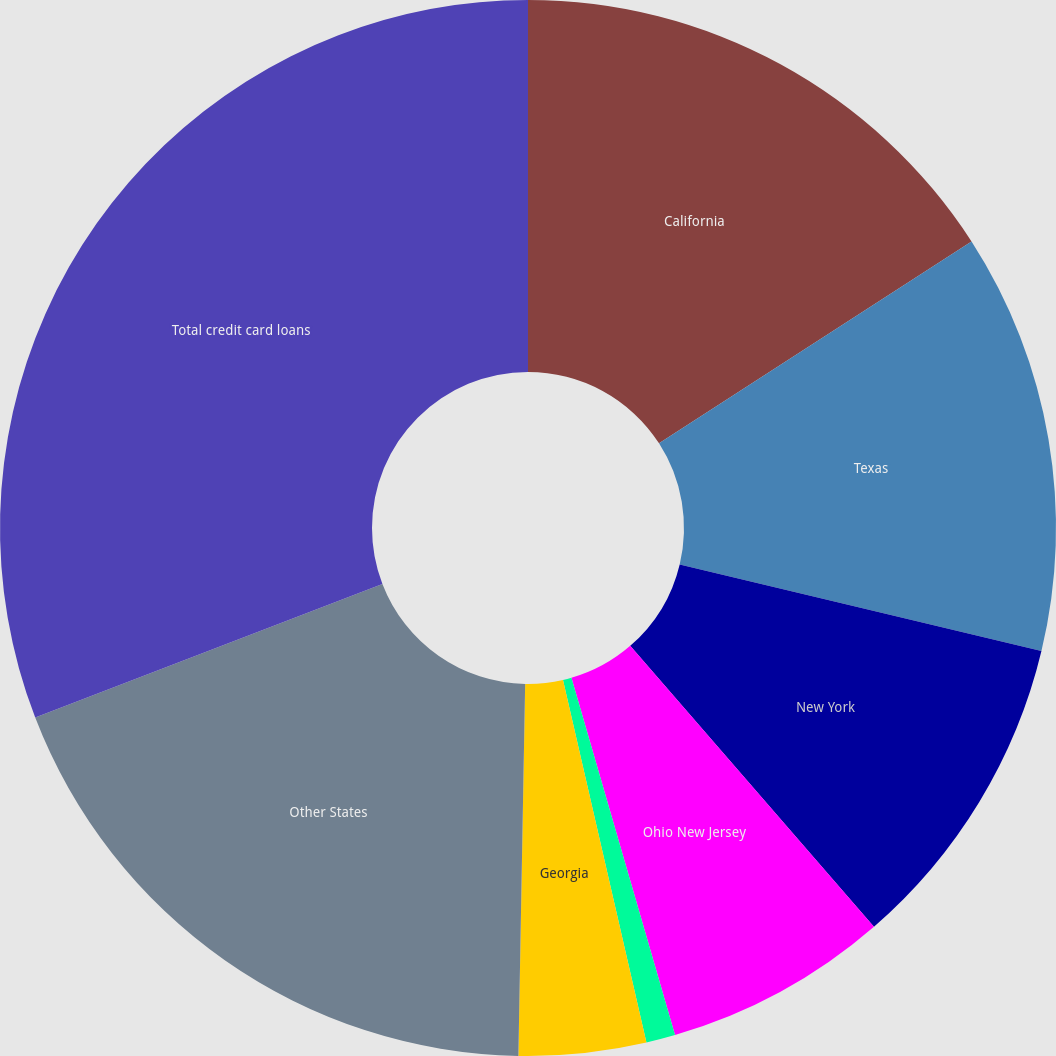Convert chart to OTSL. <chart><loc_0><loc_0><loc_500><loc_500><pie_chart><fcel>California<fcel>Texas<fcel>New York<fcel>Ohio New Jersey<fcel>Michigan<fcel>Georgia<fcel>Other States<fcel>Total credit card loans<nl><fcel>15.87%<fcel>12.87%<fcel>9.88%<fcel>6.88%<fcel>0.89%<fcel>3.89%<fcel>18.86%<fcel>30.84%<nl></chart> 